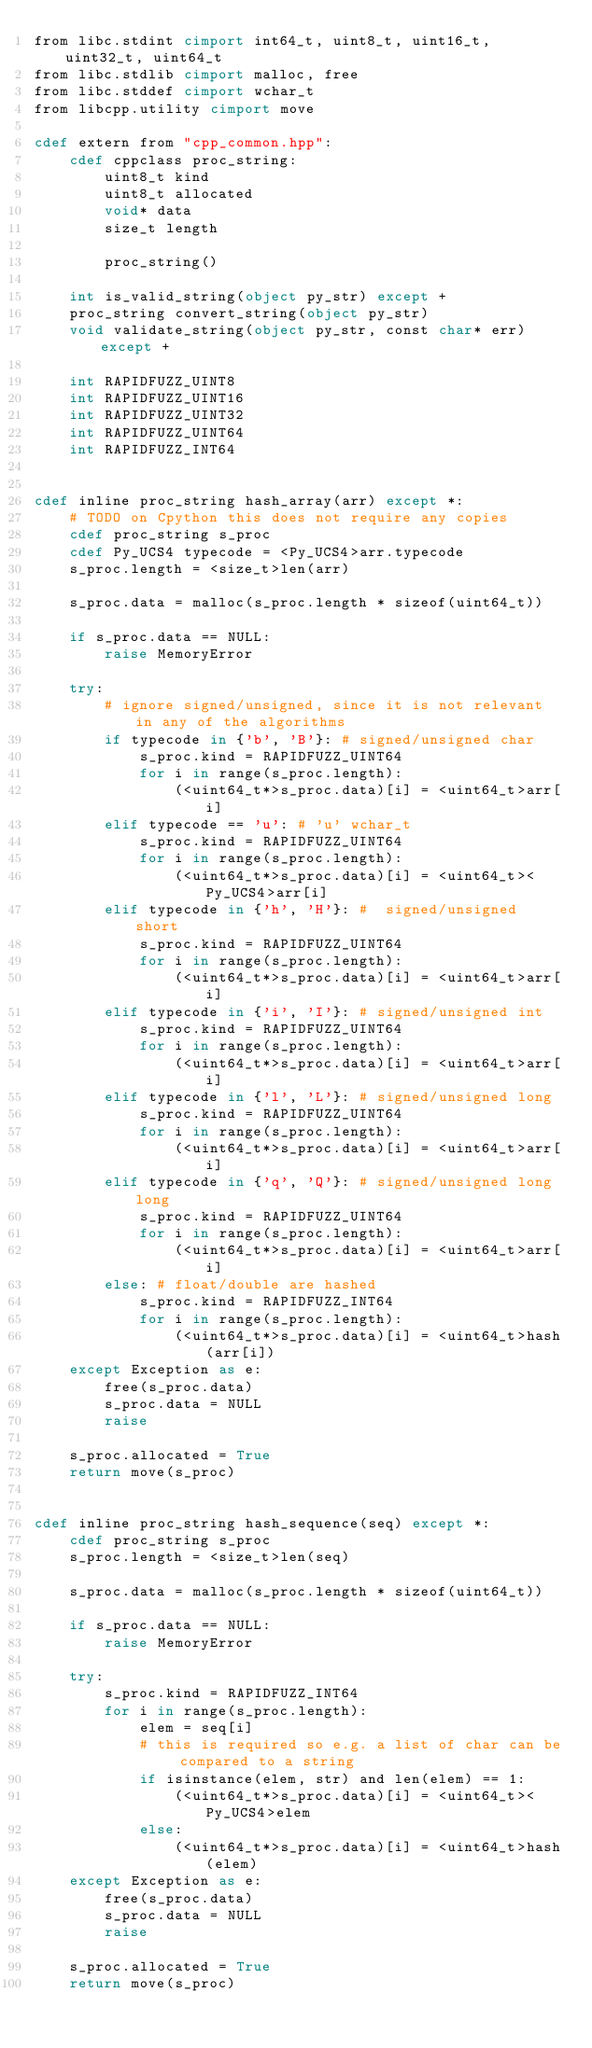<code> <loc_0><loc_0><loc_500><loc_500><_Cython_>from libc.stdint cimport int64_t, uint8_t, uint16_t, uint32_t, uint64_t
from libc.stdlib cimport malloc, free
from libc.stddef cimport wchar_t
from libcpp.utility cimport move

cdef extern from "cpp_common.hpp":
    cdef cppclass proc_string:
        uint8_t kind
        uint8_t allocated
        void* data
        size_t length

        proc_string()

    int is_valid_string(object py_str) except +
    proc_string convert_string(object py_str)
    void validate_string(object py_str, const char* err) except +

    int RAPIDFUZZ_UINT8
    int RAPIDFUZZ_UINT16
    int RAPIDFUZZ_UINT32
    int RAPIDFUZZ_UINT64
    int RAPIDFUZZ_INT64


cdef inline proc_string hash_array(arr) except *:
    # TODO on Cpython this does not require any copies
    cdef proc_string s_proc
    cdef Py_UCS4 typecode = <Py_UCS4>arr.typecode
    s_proc.length = <size_t>len(arr)

    s_proc.data = malloc(s_proc.length * sizeof(uint64_t))

    if s_proc.data == NULL:
        raise MemoryError

    try:
        # ignore signed/unsigned, since it is not relevant in any of the algorithms
        if typecode in {'b', 'B'}: # signed/unsigned char
            s_proc.kind = RAPIDFUZZ_UINT64
            for i in range(s_proc.length):
                (<uint64_t*>s_proc.data)[i] = <uint64_t>arr[i]
        elif typecode == 'u': # 'u' wchar_t
            s_proc.kind = RAPIDFUZZ_UINT64
            for i in range(s_proc.length):
                (<uint64_t*>s_proc.data)[i] = <uint64_t><Py_UCS4>arr[i]
        elif typecode in {'h', 'H'}: #  signed/unsigned short
            s_proc.kind = RAPIDFUZZ_UINT64
            for i in range(s_proc.length):
                (<uint64_t*>s_proc.data)[i] = <uint64_t>arr[i]
        elif typecode in {'i', 'I'}: # signed/unsigned int
            s_proc.kind = RAPIDFUZZ_UINT64
            for i in range(s_proc.length):
                (<uint64_t*>s_proc.data)[i] = <uint64_t>arr[i]
        elif typecode in {'l', 'L'}: # signed/unsigned long
            s_proc.kind = RAPIDFUZZ_UINT64
            for i in range(s_proc.length):
                (<uint64_t*>s_proc.data)[i] = <uint64_t>arr[i]
        elif typecode in {'q', 'Q'}: # signed/unsigned long long
            s_proc.kind = RAPIDFUZZ_UINT64
            for i in range(s_proc.length):
                (<uint64_t*>s_proc.data)[i] = <uint64_t>arr[i]
        else: # float/double are hashed
            s_proc.kind = RAPIDFUZZ_INT64
            for i in range(s_proc.length):
                (<uint64_t*>s_proc.data)[i] = <uint64_t>hash(arr[i])
    except Exception as e:
        free(s_proc.data)
        s_proc.data = NULL
        raise

    s_proc.allocated = True
    return move(s_proc)


cdef inline proc_string hash_sequence(seq) except *:
    cdef proc_string s_proc
    s_proc.length = <size_t>len(seq)

    s_proc.data = malloc(s_proc.length * sizeof(uint64_t))

    if s_proc.data == NULL:
        raise MemoryError

    try:
        s_proc.kind = RAPIDFUZZ_INT64
        for i in range(s_proc.length):
            elem = seq[i]
            # this is required so e.g. a list of char can be compared to a string
            if isinstance(elem, str) and len(elem) == 1:
                (<uint64_t*>s_proc.data)[i] = <uint64_t><Py_UCS4>elem
            else:
                (<uint64_t*>s_proc.data)[i] = <uint64_t>hash(elem)
    except Exception as e:
        free(s_proc.data)
        s_proc.data = NULL
        raise

    s_proc.allocated = True
    return move(s_proc)
</code> 